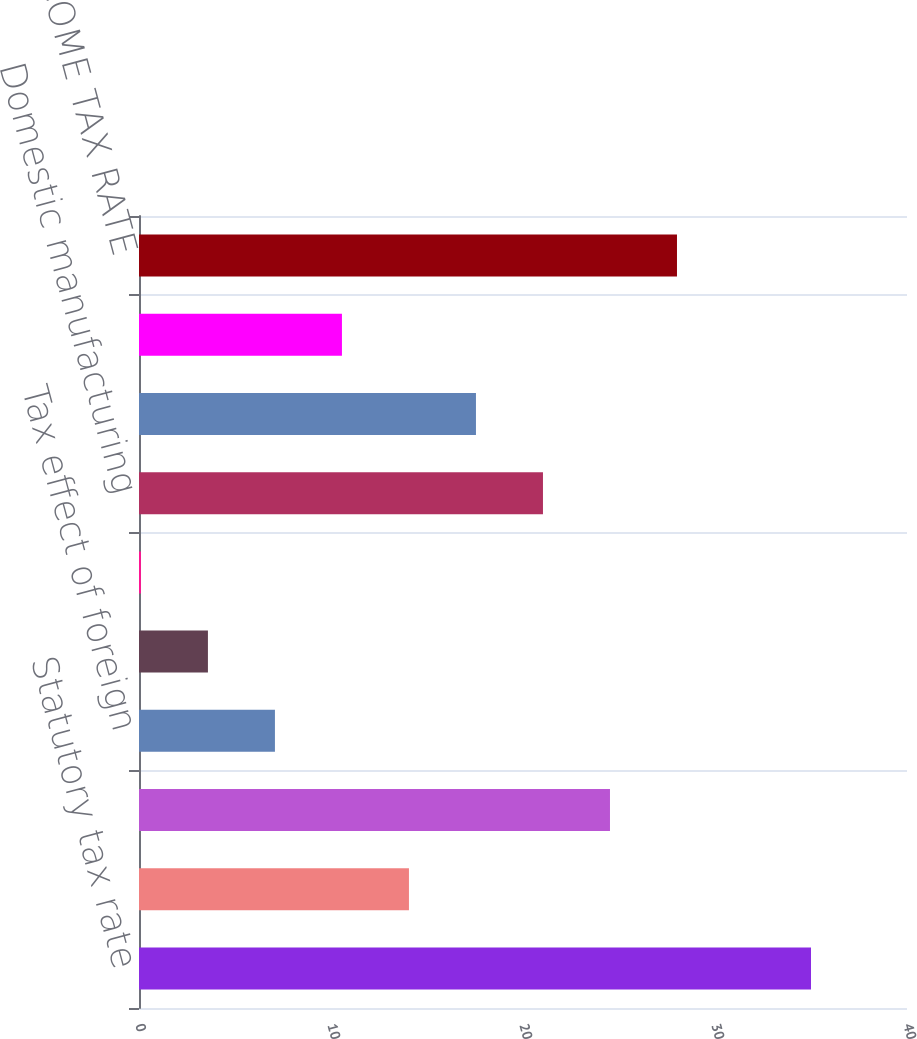Convert chart. <chart><loc_0><loc_0><loc_500><loc_500><bar_chart><fcel>Statutory tax rate<fcel>State and local income taxes<fcel>Non-United States taxes<fcel>Tax effect of foreign<fcel>Employee stock ownership plan<fcel>Change in valuation allowances<fcel>Domestic manufacturing<fcel>Adjustments for prior period<fcel>Other<fcel>EFFECTIVE INCOME TAX RATE<nl><fcel>35<fcel>14.06<fcel>24.53<fcel>7.08<fcel>3.59<fcel>0.1<fcel>21.04<fcel>17.55<fcel>10.57<fcel>28.02<nl></chart> 